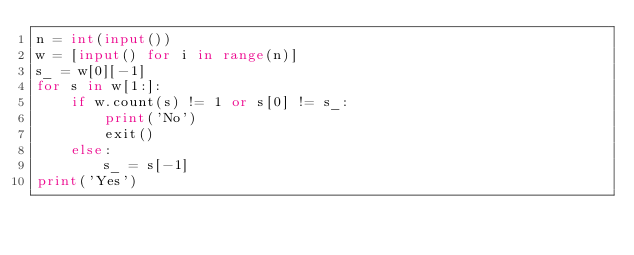Convert code to text. <code><loc_0><loc_0><loc_500><loc_500><_Python_>n = int(input())
w = [input() for i in range(n)]
s_ = w[0][-1]
for s in w[1:]:
    if w.count(s) != 1 or s[0] != s_:
        print('No')
        exit()
    else:
        s_ = s[-1]
print('Yes')</code> 